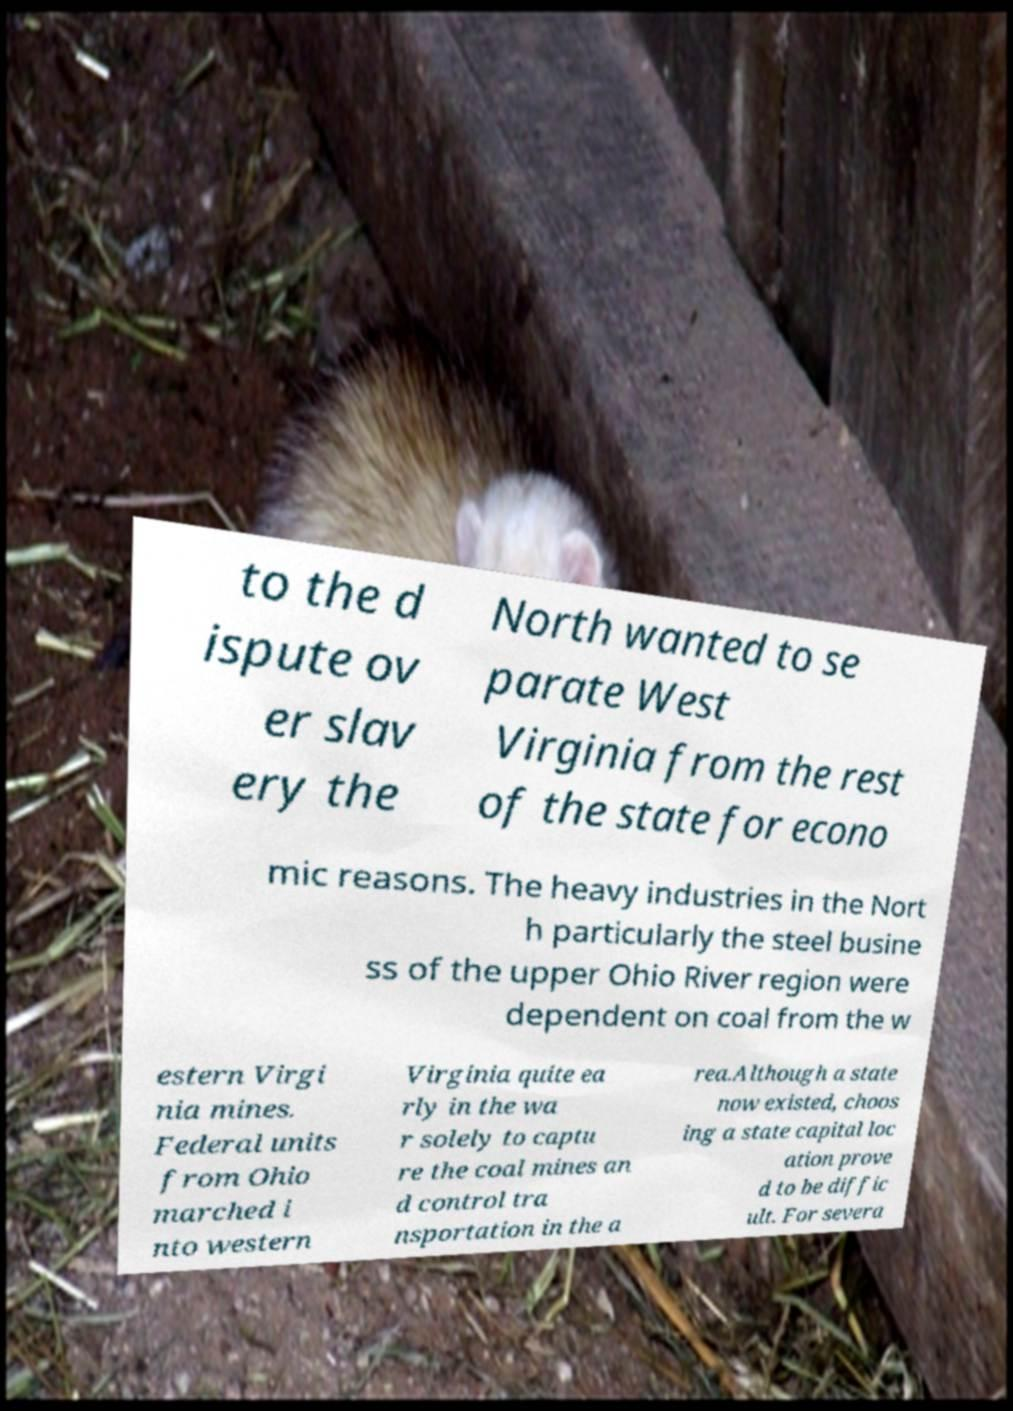For documentation purposes, I need the text within this image transcribed. Could you provide that? to the d ispute ov er slav ery the North wanted to se parate West Virginia from the rest of the state for econo mic reasons. The heavy industries in the Nort h particularly the steel busine ss of the upper Ohio River region were dependent on coal from the w estern Virgi nia mines. Federal units from Ohio marched i nto western Virginia quite ea rly in the wa r solely to captu re the coal mines an d control tra nsportation in the a rea.Although a state now existed, choos ing a state capital loc ation prove d to be diffic ult. For severa 